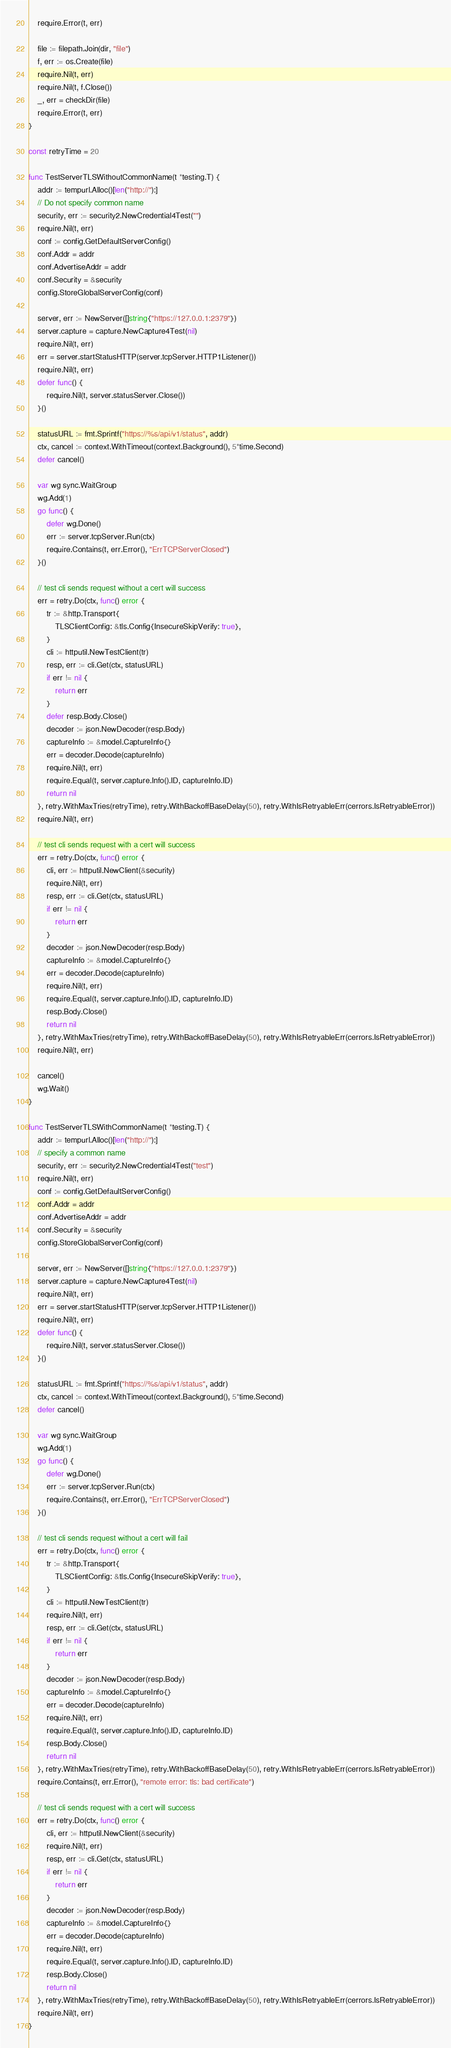<code> <loc_0><loc_0><loc_500><loc_500><_Go_>	require.Error(t, err)

	file := filepath.Join(dir, "file")
	f, err := os.Create(file)
	require.Nil(t, err)
	require.Nil(t, f.Close())
	_, err = checkDir(file)
	require.Error(t, err)
}

const retryTime = 20

func TestServerTLSWithoutCommonName(t *testing.T) {
	addr := tempurl.Alloc()[len("http://"):]
	// Do not specify common name
	security, err := security2.NewCredential4Test("")
	require.Nil(t, err)
	conf := config.GetDefaultServerConfig()
	conf.Addr = addr
	conf.AdvertiseAddr = addr
	conf.Security = &security
	config.StoreGlobalServerConfig(conf)

	server, err := NewServer([]string{"https://127.0.0.1:2379"})
	server.capture = capture.NewCapture4Test(nil)
	require.Nil(t, err)
	err = server.startStatusHTTP(server.tcpServer.HTTP1Listener())
	require.Nil(t, err)
	defer func() {
		require.Nil(t, server.statusServer.Close())
	}()

	statusURL := fmt.Sprintf("https://%s/api/v1/status", addr)
	ctx, cancel := context.WithTimeout(context.Background(), 5*time.Second)
	defer cancel()

	var wg sync.WaitGroup
	wg.Add(1)
	go func() {
		defer wg.Done()
		err := server.tcpServer.Run(ctx)
		require.Contains(t, err.Error(), "ErrTCPServerClosed")
	}()

	// test cli sends request without a cert will success
	err = retry.Do(ctx, func() error {
		tr := &http.Transport{
			TLSClientConfig: &tls.Config{InsecureSkipVerify: true},
		}
		cli := httputil.NewTestClient(tr)
		resp, err := cli.Get(ctx, statusURL)
		if err != nil {
			return err
		}
		defer resp.Body.Close()
		decoder := json.NewDecoder(resp.Body)
		captureInfo := &model.CaptureInfo{}
		err = decoder.Decode(captureInfo)
		require.Nil(t, err)
		require.Equal(t, server.capture.Info().ID, captureInfo.ID)
		return nil
	}, retry.WithMaxTries(retryTime), retry.WithBackoffBaseDelay(50), retry.WithIsRetryableErr(cerrors.IsRetryableError))
	require.Nil(t, err)

	// test cli sends request with a cert will success
	err = retry.Do(ctx, func() error {
		cli, err := httputil.NewClient(&security)
		require.Nil(t, err)
		resp, err := cli.Get(ctx, statusURL)
		if err != nil {
			return err
		}
		decoder := json.NewDecoder(resp.Body)
		captureInfo := &model.CaptureInfo{}
		err = decoder.Decode(captureInfo)
		require.Nil(t, err)
		require.Equal(t, server.capture.Info().ID, captureInfo.ID)
		resp.Body.Close()
		return nil
	}, retry.WithMaxTries(retryTime), retry.WithBackoffBaseDelay(50), retry.WithIsRetryableErr(cerrors.IsRetryableError))
	require.Nil(t, err)

	cancel()
	wg.Wait()
}

func TestServerTLSWithCommonName(t *testing.T) {
	addr := tempurl.Alloc()[len("http://"):]
	// specify a common name
	security, err := security2.NewCredential4Test("test")
	require.Nil(t, err)
	conf := config.GetDefaultServerConfig()
	conf.Addr = addr
	conf.AdvertiseAddr = addr
	conf.Security = &security
	config.StoreGlobalServerConfig(conf)

	server, err := NewServer([]string{"https://127.0.0.1:2379"})
	server.capture = capture.NewCapture4Test(nil)
	require.Nil(t, err)
	err = server.startStatusHTTP(server.tcpServer.HTTP1Listener())
	require.Nil(t, err)
	defer func() {
		require.Nil(t, server.statusServer.Close())
	}()

	statusURL := fmt.Sprintf("https://%s/api/v1/status", addr)
	ctx, cancel := context.WithTimeout(context.Background(), 5*time.Second)
	defer cancel()

	var wg sync.WaitGroup
	wg.Add(1)
	go func() {
		defer wg.Done()
		err := server.tcpServer.Run(ctx)
		require.Contains(t, err.Error(), "ErrTCPServerClosed")
	}()

	// test cli sends request without a cert will fail
	err = retry.Do(ctx, func() error {
		tr := &http.Transport{
			TLSClientConfig: &tls.Config{InsecureSkipVerify: true},
		}
		cli := httputil.NewTestClient(tr)
		require.Nil(t, err)
		resp, err := cli.Get(ctx, statusURL)
		if err != nil {
			return err
		}
		decoder := json.NewDecoder(resp.Body)
		captureInfo := &model.CaptureInfo{}
		err = decoder.Decode(captureInfo)
		require.Nil(t, err)
		require.Equal(t, server.capture.Info().ID, captureInfo.ID)
		resp.Body.Close()
		return nil
	}, retry.WithMaxTries(retryTime), retry.WithBackoffBaseDelay(50), retry.WithIsRetryableErr(cerrors.IsRetryableError))
	require.Contains(t, err.Error(), "remote error: tls: bad certificate")

	// test cli sends request with a cert will success
	err = retry.Do(ctx, func() error {
		cli, err := httputil.NewClient(&security)
		require.Nil(t, err)
		resp, err := cli.Get(ctx, statusURL)
		if err != nil {
			return err
		}
		decoder := json.NewDecoder(resp.Body)
		captureInfo := &model.CaptureInfo{}
		err = decoder.Decode(captureInfo)
		require.Nil(t, err)
		require.Equal(t, server.capture.Info().ID, captureInfo.ID)
		resp.Body.Close()
		return nil
	}, retry.WithMaxTries(retryTime), retry.WithBackoffBaseDelay(50), retry.WithIsRetryableErr(cerrors.IsRetryableError))
	require.Nil(t, err)
}
</code> 